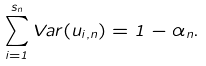<formula> <loc_0><loc_0><loc_500><loc_500>\sum _ { i = 1 } ^ { s _ { n } } V a r ( u _ { i , n } ) = 1 - \alpha _ { n } .</formula> 